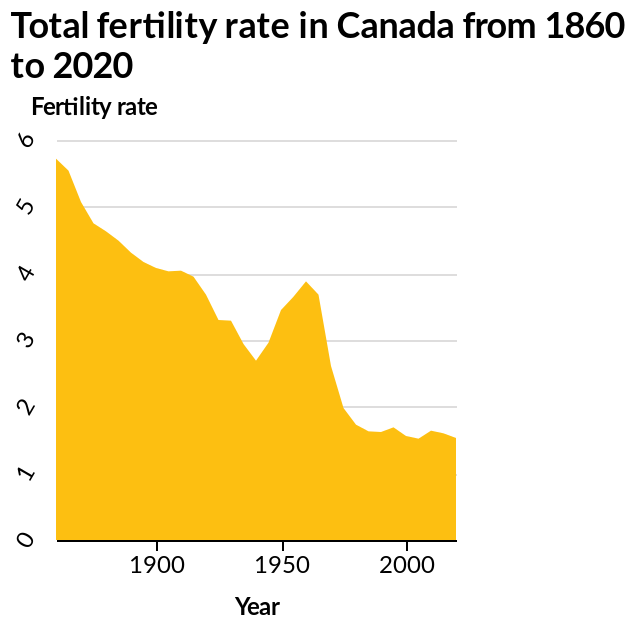<image>
What is the label of the area chart?  The area chart is labeled "Total fertility rate in Canada from 1860 to 2020." What is the range of the x-axis in the area chart?  The x-axis shows the Year using a linear scale of the range 1900 to 2000. What does the y-axis represent in this line plot?  The y-axis represents the Fertility rate. What is the trend of fertility since 1860?  Fertility has been on a decline since 1860. Describe the following image in detail Here a area chart is labeled Total fertility rate in Canada from 1860 to 2020. The y-axis measures Fertility rate using linear scale from 0 to 6 while the x-axis shows Year using linear scale of range 1900 to 2000. 